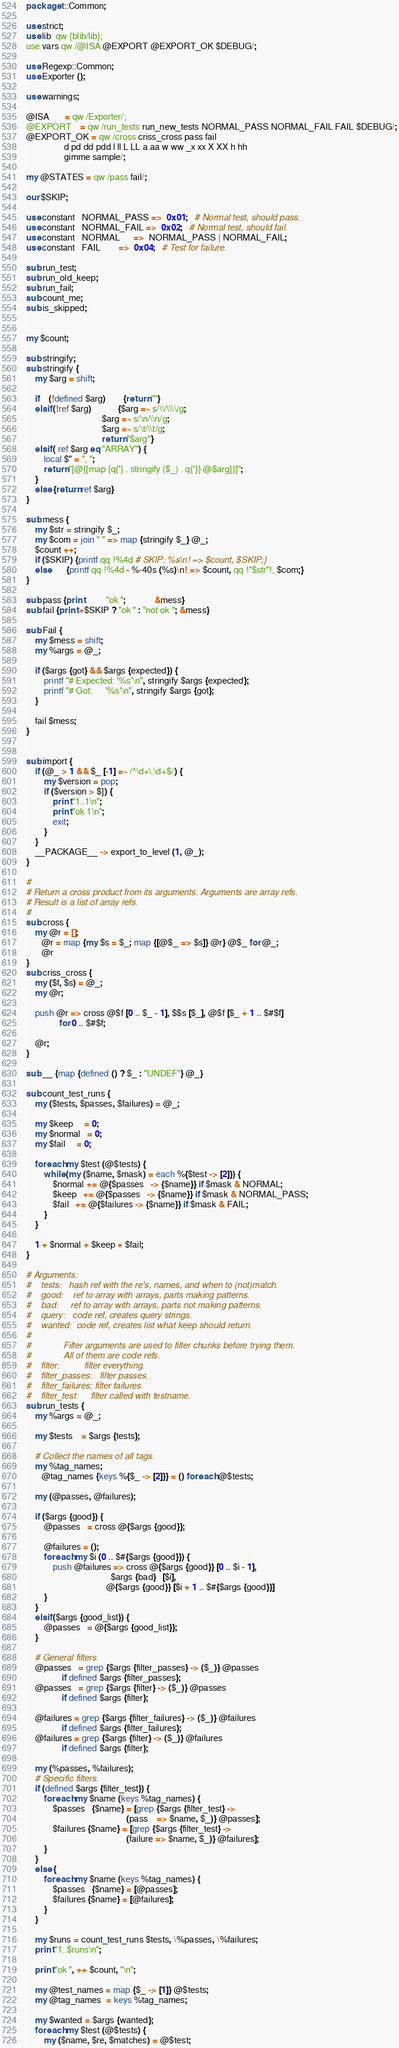Convert code to text. <code><loc_0><loc_0><loc_500><loc_500><_Perl_>package t::Common;

use strict;
use lib  qw {blib/lib};
use vars qw /@ISA @EXPORT @EXPORT_OK $DEBUG/;

use Regexp::Common;
use Exporter ();

use warnings;

@ISA       = qw /Exporter/;
@EXPORT    = qw /run_tests run_new_tests NORMAL_PASS NORMAL_FAIL FAIL $DEBUG/;
@EXPORT_OK = qw /cross criss_cross pass fail
                 d pd dd pdd l ll L LL a aa w ww _x xx X XX h hh
                 gimme sample/;

my @STATES = qw /pass fail/;

our $SKIP;

use constant   NORMAL_PASS =>  0x01;   # Normal test, should pass.
use constant   NORMAL_FAIL =>  0x02;   # Normal test, should fail.
use constant   NORMAL      =>  NORMAL_PASS | NORMAL_FAIL;
use constant   FAIL        =>  0x04;   # Test for failure.

sub run_test;
sub run_old_keep;
sub run_fail;
sub count_me;
sub is_skipped;


my $count;

sub stringify;
sub stringify {
    my $arg = shift;

    if    (!defined $arg)        {return ""}
    elsif (!ref $arg)            {$arg =~ s/\\/\\\\/g;
                                  $arg =~ s/\n/\\n/g;
                                  $arg =~ s/\t/\\t/g;
                                  return "$arg"}
    elsif ( ref $arg eq "ARRAY") {
        local $" = ", ";
        return "[@{[map {q{'} . stringify ($_) . q{'}} @$arg]}]";
    }
    else {return ref $arg}
}

sub mess {
    my $str = stringify $_;
    my $com = join " " => map {stringify $_} @_;
    $count ++;
    if ($SKIP) {printf qq !%4d # SKIP: %s\n! => $count, $SKIP;}
    else       {printf qq !%4d - %-40s (%s)\n! => $count, qq !"$str"!, $com;}
}

sub pass {print          "ok ";             &mess}
sub fail {print +$SKIP ? "ok " : "not ok "; &mess}

sub Fail {
    my $mess = shift;
    my %args = @_;

    if ($args {got} && $args {expected}) {
        printf "# Expected: '%s'\n", stringify $args {expected};
        printf "# Got:      '%s'\n", stringify $args {got};
    }

    fail $mess;
}


sub import {
    if (@_ > 1 && $_ [-1] =~ /^\d+\.\d+$/) {
        my $version = pop;
        if ($version > $]) {
            print "1..1\n";
            print "ok 1\n";
            exit;
        }
    }
    __PACKAGE__ -> export_to_level (1, @_);
}

#
# Return a cross product from its arguments. Arguments are array refs.
# Result is a list of array refs.
#
sub cross {
    my @r = [];
       @r = map {my $s = $_; map {[@$_ => $s]} @r} @$_ for @_;
       @r
}
sub criss_cross {
    my ($f, $s) = @_;
    my @r;

    push @r => cross @$f [0 .. $_ - 1], $$s [$_], @$f [$_ + 1 .. $#$f]
               for 0 .. $#$f;

    @r;
}

sub __ {map {defined () ? $_ : "UNDEF"} @_}

sub count_test_runs {
    my ($tests, $passes, $failures) = @_;

    my $keep     = 0;
    my $normal   = 0;
    my $fail     = 0;

    foreach my $test (@$tests) {
        while (my ($name, $mask) = each %{$test -> [2]}) {
            $normal += @{$passes   -> {$name}} if $mask & NORMAL;
            $keep   += @{$passes   -> {$name}} if $mask & NORMAL_PASS;
            $fail   += @{$failures -> {$name}} if $mask & FAIL;
        }
    }

    1 + $normal + $keep + $fail;
}

# Arguments:
#    tests:   hash ref with the re's, names, and when to (not)match.
#    good:    ref to array with arrays, parts making patterns.
#    bad:     ref to array with arrays, parts not making patterns.
#    query:   code ref, creates query strings.
#    wanted:  code ref, creates list what keep should return.
#
#             Filter arguments are used to filter chunks before trying them.
#             All of them are code refs.
#    filter:          filter everything.
#    filter_passes:   filter passes.
#    filter_failures: filter failures.
#    filter_test:     filter called with testname.
sub run_tests {
    my %args = @_;

    my $tests    = $args {tests};

    # Collect the names of all tags.
    my %tag_names;
       @tag_names {keys %{$_ -> [2]}} = () foreach @$tests;

    my (@passes, @failures);

    if ($args {good}) {
        @passes   = cross @{$args {good}};

        @failures = ();
        foreach my $i (0 .. $#{$args {good}}) {
            push @failures => cross @{$args {good}} [0 .. $i - 1],
                                      $args {bad}   [$i],
                                    @{$args {good}} [$i + 1 .. $#{$args {good}}]
        }
    }
    elsif ($args {good_list}) {
        @passes   = @{$args {good_list}};
    }

    # General filters.
    @passes   = grep {$args {filter_passes} -> ($_)} @passes
                if defined $args {filter_passes};
    @passes   = grep {$args {filter} -> ($_)} @passes
                if defined $args {filter};

    @failures = grep {$args {filter_failures} -> ($_)} @failures
                if defined $args {filter_failures};
    @failures = grep {$args {filter} -> ($_)} @failures
                if defined $args {filter};

    my (%passes, %failures);
    # Specific filters.
    if (defined $args {filter_test}) {
        foreach my $name (keys %tag_names) {
            $passes   {$name} = [grep {$args {filter_test} ->
                                             (pass    => $name, $_)} @passes];
            $failures {$name} = [grep {$args {filter_test} ->
                                             (failure => $name, $_)} @failures];
        }
    }
    else {
        foreach my $name (keys %tag_names) {
            $passes   {$name} = [@passes];
            $failures {$name} = [@failures];
        }
    }

    my $runs = count_test_runs $tests, \%passes, \%failures;
    print "1..$runs\n";

    print "ok ", ++ $count, "\n";

    my @test_names = map {$_ -> [1]} @$tests;
    my @tag_names  = keys %tag_names;

    my $wanted = $args {wanted};
    foreach my $test (@$tests) {
        my ($name, $re, $matches) = @$test;
</code> 